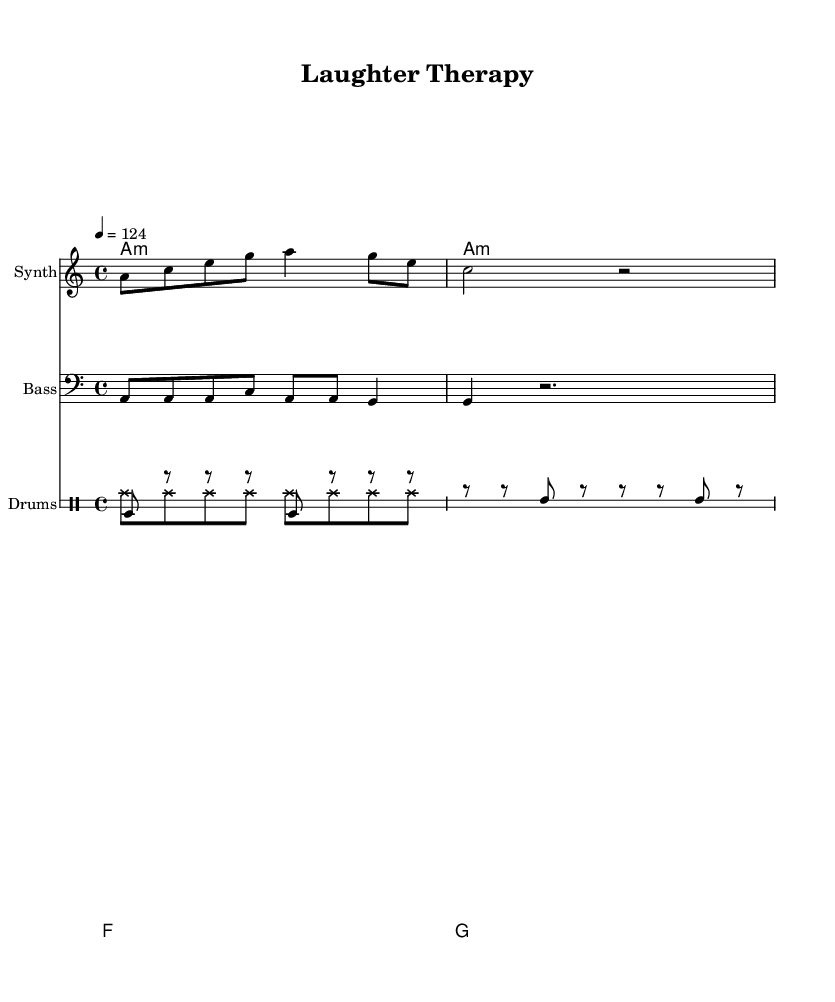What is the time signature of this music? The time signature is given at the beginning of the score as 4/4, indicating that there are four beats in a measure and the quarter note gets one beat.
Answer: 4/4 What is the key signature of this music? The key signature is indicated by the presence of one flat, which signifies the key of A minor (the relative minor of C major).
Answer: A minor What tempo marking is given for this piece? The tempo marking is 4 = 124, meaning that the quarter note is to be played at a speed of 124 beats per minute.
Answer: 124 How many measures are in the melody? By counting the segments in the synth melody, there are four measures present in the score.
Answer: Four What kind of rhythm is predominantly used in the drum section? The drum section primarily uses a mixture of bass drum and snare drum, with a steady eighth-note rhythm interspersed with rests.
Answer: Eighth-note rhythm Which chord appears at the end of the piece? The final chord in the chord progression is a G major chord, which appears at the last measure of the score.
Answer: G major What instrument is indicated for the melody? The instrument specified for the melody is a synth, as noted in the staff designation in the score.
Answer: Synth 